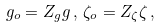<formula> <loc_0><loc_0><loc_500><loc_500>g _ { o } = Z _ { g } g \, , \, \zeta _ { o } = Z _ { \zeta } \zeta \, , \,</formula> 